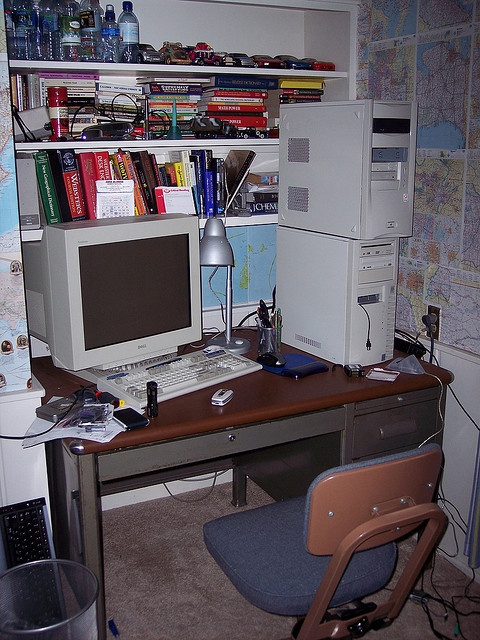Describe the objects in this image and their specific colors. I can see chair in darkgray, black, maroon, and gray tones, tv in darkgray, black, and gray tones, book in darkgray, black, gray, and lightgray tones, keyboard in darkgray, black, and gray tones, and keyboard in darkgray, gray, lightgray, and black tones in this image. 